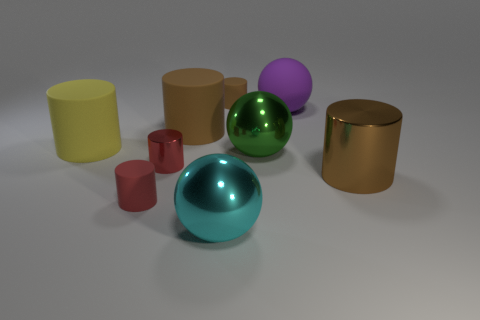What is the color of the shiny cylinder that is the same size as the green metal sphere?
Your answer should be very brief. Brown. Is there another sphere that has the same color as the matte sphere?
Offer a very short reply. No. Are there fewer tiny red rubber cylinders right of the small metal cylinder than shiny balls behind the large cyan object?
Offer a very short reply. Yes. There is a cylinder that is both right of the large brown matte thing and behind the green metal sphere; what is it made of?
Your answer should be very brief. Rubber. Does the cyan metallic thing have the same shape as the small thing to the left of the small red metal cylinder?
Your answer should be compact. No. What number of other objects are the same size as the cyan thing?
Ensure brevity in your answer.  5. Are there more large purple rubber objects than tiny blocks?
Your answer should be very brief. Yes. How many matte objects are to the right of the small metallic object and in front of the small brown rubber cylinder?
Offer a terse response. 2. What is the shape of the metal thing right of the rubber ball behind the large object right of the large purple matte sphere?
Keep it short and to the point. Cylinder. Is there any other thing that is the same shape as the yellow object?
Provide a succinct answer. Yes. 